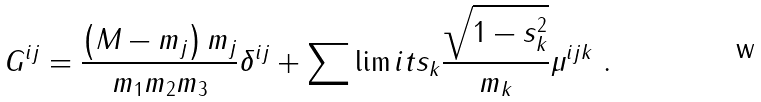<formula> <loc_0><loc_0><loc_500><loc_500>G ^ { i j } = \frac { \left ( M - m _ { j } \right ) m _ { j } } { m _ { 1 } m _ { 2 } m _ { 3 } } \delta ^ { i j } + \sum \lim i t s _ { k } \frac { \sqrt { 1 - s _ { k } ^ { 2 } } } { m _ { k } } \mu ^ { i j k } \ .</formula> 